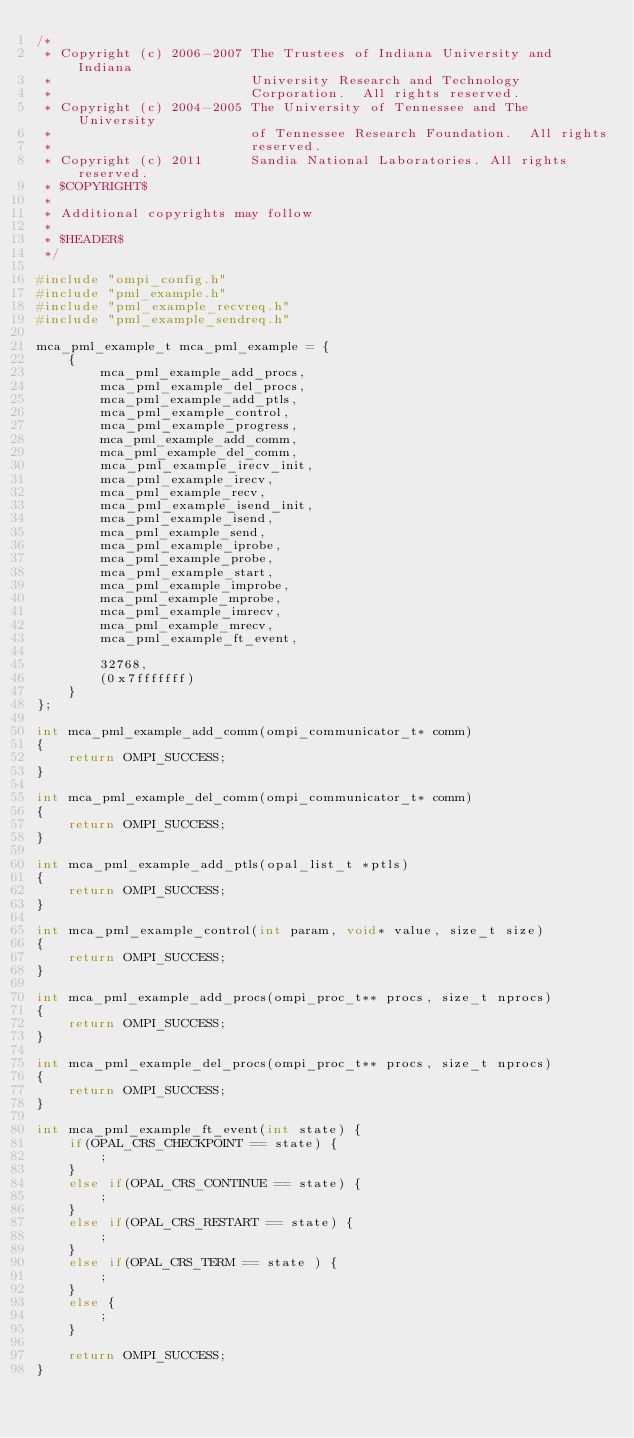<code> <loc_0><loc_0><loc_500><loc_500><_C_>/*
 * Copyright (c) 2006-2007 The Trustees of Indiana University and Indiana
 *                         University Research and Technology
 *                         Corporation.  All rights reserved.
 * Copyright (c) 2004-2005 The University of Tennessee and The University
 *                         of Tennessee Research Foundation.  All rights
 *                         reserved.
 * Copyright (c) 2011      Sandia National Laboratories. All rights reserved.
 * $COPYRIGHT$
 *
 * Additional copyrights may follow
 *
 * $HEADER$
 */

#include "ompi_config.h"
#include "pml_example.h"
#include "pml_example_recvreq.h"
#include "pml_example_sendreq.h"

mca_pml_example_t mca_pml_example = {
    {
        mca_pml_example_add_procs,
        mca_pml_example_del_procs,
        mca_pml_example_add_ptls,
        mca_pml_example_control,
        mca_pml_example_progress,
        mca_pml_example_add_comm,
        mca_pml_example_del_comm,
        mca_pml_example_irecv_init,
        mca_pml_example_irecv,
        mca_pml_example_recv,
        mca_pml_example_isend_init,
        mca_pml_example_isend,
        mca_pml_example_send,
        mca_pml_example_iprobe,
        mca_pml_example_probe,
        mca_pml_example_start,
        mca_pml_example_improbe,
        mca_pml_example_mprobe,
        mca_pml_example_imrecv,
        mca_pml_example_mrecv,
        mca_pml_example_ft_event,

        32768,
        (0x7fffffff)
    }
};

int mca_pml_example_add_comm(ompi_communicator_t* comm)
{
    return OMPI_SUCCESS;
}

int mca_pml_example_del_comm(ompi_communicator_t* comm)
{
    return OMPI_SUCCESS;
}

int mca_pml_example_add_ptls(opal_list_t *ptls)
{
    return OMPI_SUCCESS;
}

int mca_pml_example_control(int param, void* value, size_t size)
{
    return OMPI_SUCCESS;
}

int mca_pml_example_add_procs(ompi_proc_t** procs, size_t nprocs)
{
    return OMPI_SUCCESS;
}

int mca_pml_example_del_procs(ompi_proc_t** procs, size_t nprocs)
{
    return OMPI_SUCCESS;
}

int mca_pml_example_ft_event(int state) {
    if(OPAL_CRS_CHECKPOINT == state) {
        ;
    }
    else if(OPAL_CRS_CONTINUE == state) {
        ;
    }
    else if(OPAL_CRS_RESTART == state) {
        ;
    }
    else if(OPAL_CRS_TERM == state ) {
        ;
    }
    else {
        ;
    }
    
    return OMPI_SUCCESS;
}
</code> 